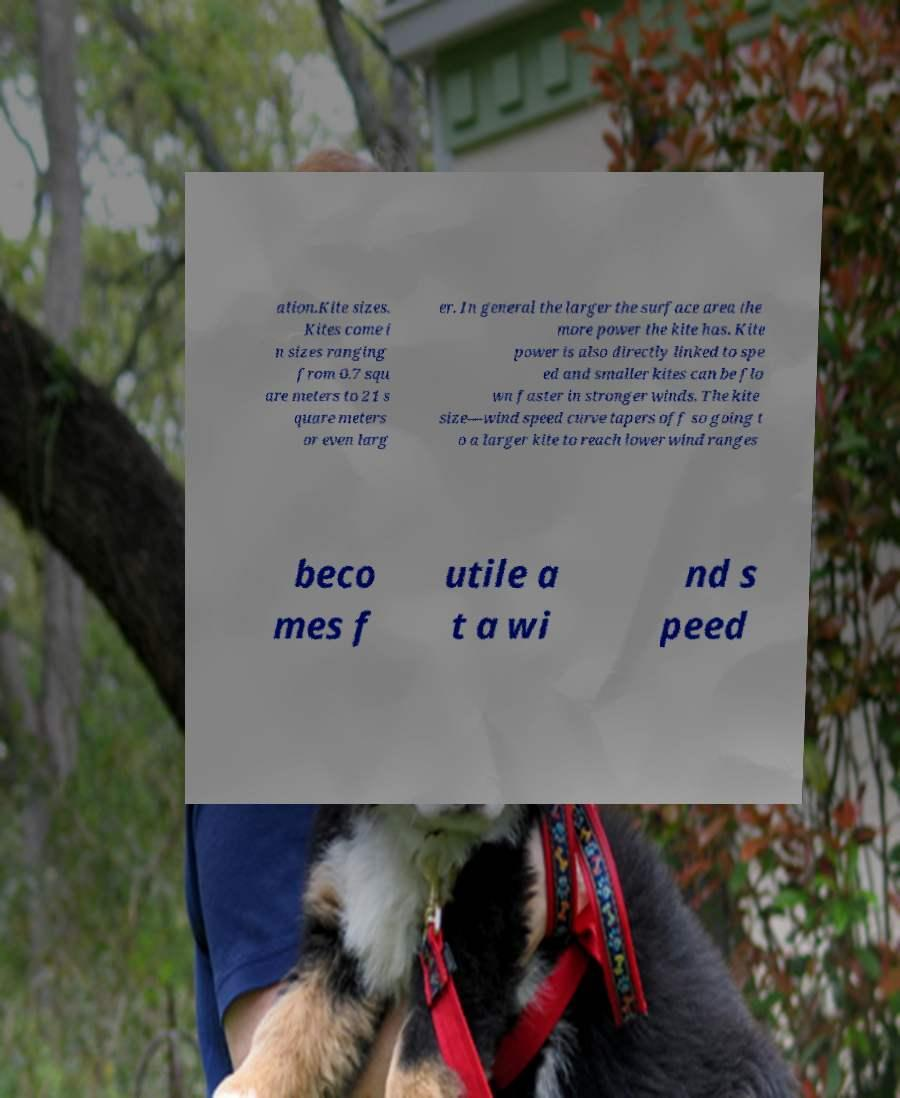What messages or text are displayed in this image? I need them in a readable, typed format. ation.Kite sizes. Kites come i n sizes ranging from 0.7 squ are meters to 21 s quare meters or even larg er. In general the larger the surface area the more power the kite has. Kite power is also directly linked to spe ed and smaller kites can be flo wn faster in stronger winds. The kite size—wind speed curve tapers off so going t o a larger kite to reach lower wind ranges beco mes f utile a t a wi nd s peed 